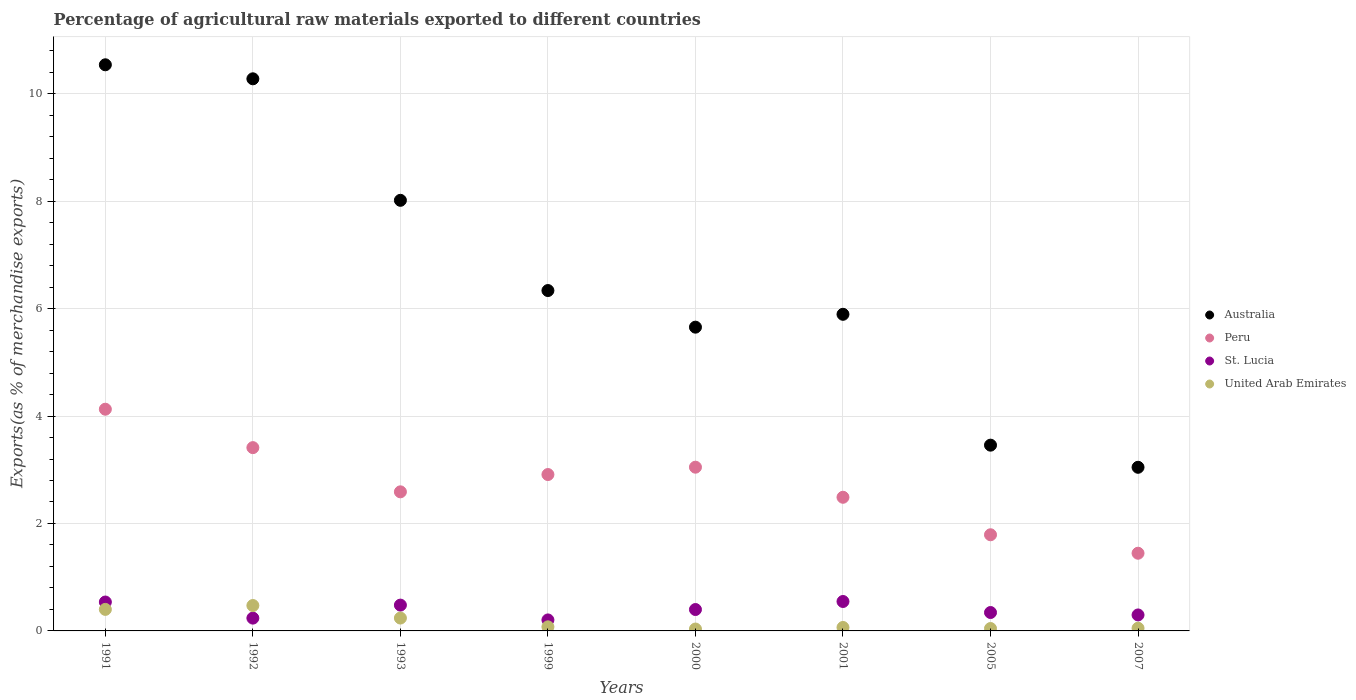What is the percentage of exports to different countries in Peru in 2001?
Your answer should be very brief. 2.49. Across all years, what is the maximum percentage of exports to different countries in Peru?
Provide a succinct answer. 4.13. Across all years, what is the minimum percentage of exports to different countries in St. Lucia?
Offer a terse response. 0.2. In which year was the percentage of exports to different countries in United Arab Emirates minimum?
Make the answer very short. 2000. What is the total percentage of exports to different countries in United Arab Emirates in the graph?
Your response must be concise. 1.38. What is the difference between the percentage of exports to different countries in United Arab Emirates in 2001 and that in 2005?
Offer a terse response. 0.02. What is the difference between the percentage of exports to different countries in United Arab Emirates in 1999 and the percentage of exports to different countries in Australia in 2001?
Provide a short and direct response. -5.82. What is the average percentage of exports to different countries in United Arab Emirates per year?
Make the answer very short. 0.17. In the year 2001, what is the difference between the percentage of exports to different countries in Australia and percentage of exports to different countries in United Arab Emirates?
Ensure brevity in your answer.  5.83. What is the ratio of the percentage of exports to different countries in Peru in 1993 to that in 2001?
Provide a succinct answer. 1.04. What is the difference between the highest and the second highest percentage of exports to different countries in Australia?
Your answer should be very brief. 0.26. What is the difference between the highest and the lowest percentage of exports to different countries in St. Lucia?
Provide a succinct answer. 0.34. Is the sum of the percentage of exports to different countries in St. Lucia in 1991 and 1993 greater than the maximum percentage of exports to different countries in Australia across all years?
Provide a succinct answer. No. Is it the case that in every year, the sum of the percentage of exports to different countries in United Arab Emirates and percentage of exports to different countries in Australia  is greater than the sum of percentage of exports to different countries in Peru and percentage of exports to different countries in St. Lucia?
Provide a succinct answer. Yes. Is the percentage of exports to different countries in United Arab Emirates strictly greater than the percentage of exports to different countries in St. Lucia over the years?
Keep it short and to the point. No. How many dotlines are there?
Your response must be concise. 4. Where does the legend appear in the graph?
Your answer should be very brief. Center right. How are the legend labels stacked?
Offer a very short reply. Vertical. What is the title of the graph?
Offer a terse response. Percentage of agricultural raw materials exported to different countries. What is the label or title of the X-axis?
Offer a terse response. Years. What is the label or title of the Y-axis?
Give a very brief answer. Exports(as % of merchandise exports). What is the Exports(as % of merchandise exports) in Australia in 1991?
Provide a succinct answer. 10.54. What is the Exports(as % of merchandise exports) in Peru in 1991?
Make the answer very short. 4.13. What is the Exports(as % of merchandise exports) in St. Lucia in 1991?
Offer a terse response. 0.54. What is the Exports(as % of merchandise exports) of United Arab Emirates in 1991?
Offer a very short reply. 0.4. What is the Exports(as % of merchandise exports) of Australia in 1992?
Offer a terse response. 10.28. What is the Exports(as % of merchandise exports) of Peru in 1992?
Offer a terse response. 3.41. What is the Exports(as % of merchandise exports) in St. Lucia in 1992?
Provide a short and direct response. 0.24. What is the Exports(as % of merchandise exports) in United Arab Emirates in 1992?
Your response must be concise. 0.47. What is the Exports(as % of merchandise exports) of Australia in 1993?
Your answer should be very brief. 8.02. What is the Exports(as % of merchandise exports) in Peru in 1993?
Make the answer very short. 2.59. What is the Exports(as % of merchandise exports) in St. Lucia in 1993?
Offer a very short reply. 0.48. What is the Exports(as % of merchandise exports) of United Arab Emirates in 1993?
Give a very brief answer. 0.24. What is the Exports(as % of merchandise exports) in Australia in 1999?
Provide a succinct answer. 6.34. What is the Exports(as % of merchandise exports) of Peru in 1999?
Offer a terse response. 2.91. What is the Exports(as % of merchandise exports) of St. Lucia in 1999?
Offer a very short reply. 0.2. What is the Exports(as % of merchandise exports) in United Arab Emirates in 1999?
Ensure brevity in your answer.  0.08. What is the Exports(as % of merchandise exports) of Australia in 2000?
Ensure brevity in your answer.  5.65. What is the Exports(as % of merchandise exports) in Peru in 2000?
Give a very brief answer. 3.05. What is the Exports(as % of merchandise exports) in St. Lucia in 2000?
Provide a succinct answer. 0.4. What is the Exports(as % of merchandise exports) of United Arab Emirates in 2000?
Provide a short and direct response. 0.04. What is the Exports(as % of merchandise exports) in Australia in 2001?
Give a very brief answer. 5.89. What is the Exports(as % of merchandise exports) of Peru in 2001?
Offer a terse response. 2.49. What is the Exports(as % of merchandise exports) in St. Lucia in 2001?
Ensure brevity in your answer.  0.55. What is the Exports(as % of merchandise exports) in United Arab Emirates in 2001?
Offer a very short reply. 0.06. What is the Exports(as % of merchandise exports) of Australia in 2005?
Offer a very short reply. 3.46. What is the Exports(as % of merchandise exports) of Peru in 2005?
Your response must be concise. 1.79. What is the Exports(as % of merchandise exports) of St. Lucia in 2005?
Your answer should be very brief. 0.34. What is the Exports(as % of merchandise exports) in United Arab Emirates in 2005?
Provide a succinct answer. 0.04. What is the Exports(as % of merchandise exports) of Australia in 2007?
Ensure brevity in your answer.  3.05. What is the Exports(as % of merchandise exports) of Peru in 2007?
Your answer should be very brief. 1.45. What is the Exports(as % of merchandise exports) of St. Lucia in 2007?
Make the answer very short. 0.3. What is the Exports(as % of merchandise exports) in United Arab Emirates in 2007?
Provide a short and direct response. 0.05. Across all years, what is the maximum Exports(as % of merchandise exports) in Australia?
Provide a succinct answer. 10.54. Across all years, what is the maximum Exports(as % of merchandise exports) of Peru?
Your answer should be very brief. 4.13. Across all years, what is the maximum Exports(as % of merchandise exports) in St. Lucia?
Keep it short and to the point. 0.55. Across all years, what is the maximum Exports(as % of merchandise exports) in United Arab Emirates?
Provide a short and direct response. 0.47. Across all years, what is the minimum Exports(as % of merchandise exports) of Australia?
Make the answer very short. 3.05. Across all years, what is the minimum Exports(as % of merchandise exports) of Peru?
Your answer should be compact. 1.45. Across all years, what is the minimum Exports(as % of merchandise exports) of St. Lucia?
Ensure brevity in your answer.  0.2. Across all years, what is the minimum Exports(as % of merchandise exports) of United Arab Emirates?
Provide a short and direct response. 0.04. What is the total Exports(as % of merchandise exports) in Australia in the graph?
Your answer should be very brief. 53.22. What is the total Exports(as % of merchandise exports) in Peru in the graph?
Your answer should be compact. 21.81. What is the total Exports(as % of merchandise exports) of St. Lucia in the graph?
Your answer should be very brief. 3.05. What is the total Exports(as % of merchandise exports) in United Arab Emirates in the graph?
Your response must be concise. 1.38. What is the difference between the Exports(as % of merchandise exports) of Australia in 1991 and that in 1992?
Ensure brevity in your answer.  0.26. What is the difference between the Exports(as % of merchandise exports) of Peru in 1991 and that in 1992?
Your answer should be very brief. 0.72. What is the difference between the Exports(as % of merchandise exports) in St. Lucia in 1991 and that in 1992?
Your answer should be very brief. 0.3. What is the difference between the Exports(as % of merchandise exports) in United Arab Emirates in 1991 and that in 1992?
Offer a very short reply. -0.07. What is the difference between the Exports(as % of merchandise exports) in Australia in 1991 and that in 1993?
Keep it short and to the point. 2.52. What is the difference between the Exports(as % of merchandise exports) in Peru in 1991 and that in 1993?
Provide a short and direct response. 1.54. What is the difference between the Exports(as % of merchandise exports) of St. Lucia in 1991 and that in 1993?
Your response must be concise. 0.06. What is the difference between the Exports(as % of merchandise exports) in United Arab Emirates in 1991 and that in 1993?
Provide a short and direct response. 0.16. What is the difference between the Exports(as % of merchandise exports) in Australia in 1991 and that in 1999?
Your response must be concise. 4.2. What is the difference between the Exports(as % of merchandise exports) in Peru in 1991 and that in 1999?
Your answer should be very brief. 1.22. What is the difference between the Exports(as % of merchandise exports) of St. Lucia in 1991 and that in 1999?
Provide a short and direct response. 0.33. What is the difference between the Exports(as % of merchandise exports) in United Arab Emirates in 1991 and that in 1999?
Provide a succinct answer. 0.32. What is the difference between the Exports(as % of merchandise exports) in Australia in 1991 and that in 2000?
Provide a short and direct response. 4.88. What is the difference between the Exports(as % of merchandise exports) of Peru in 1991 and that in 2000?
Make the answer very short. 1.08. What is the difference between the Exports(as % of merchandise exports) of St. Lucia in 1991 and that in 2000?
Your response must be concise. 0.14. What is the difference between the Exports(as % of merchandise exports) of United Arab Emirates in 1991 and that in 2000?
Ensure brevity in your answer.  0.37. What is the difference between the Exports(as % of merchandise exports) in Australia in 1991 and that in 2001?
Your answer should be very brief. 4.64. What is the difference between the Exports(as % of merchandise exports) of Peru in 1991 and that in 2001?
Provide a succinct answer. 1.64. What is the difference between the Exports(as % of merchandise exports) of St. Lucia in 1991 and that in 2001?
Keep it short and to the point. -0.01. What is the difference between the Exports(as % of merchandise exports) of United Arab Emirates in 1991 and that in 2001?
Keep it short and to the point. 0.34. What is the difference between the Exports(as % of merchandise exports) of Australia in 1991 and that in 2005?
Offer a terse response. 7.08. What is the difference between the Exports(as % of merchandise exports) in Peru in 1991 and that in 2005?
Offer a very short reply. 2.34. What is the difference between the Exports(as % of merchandise exports) of St. Lucia in 1991 and that in 2005?
Make the answer very short. 0.2. What is the difference between the Exports(as % of merchandise exports) in United Arab Emirates in 1991 and that in 2005?
Ensure brevity in your answer.  0.36. What is the difference between the Exports(as % of merchandise exports) in Australia in 1991 and that in 2007?
Ensure brevity in your answer.  7.49. What is the difference between the Exports(as % of merchandise exports) of Peru in 1991 and that in 2007?
Ensure brevity in your answer.  2.68. What is the difference between the Exports(as % of merchandise exports) of St. Lucia in 1991 and that in 2007?
Your response must be concise. 0.24. What is the difference between the Exports(as % of merchandise exports) in United Arab Emirates in 1991 and that in 2007?
Provide a succinct answer. 0.35. What is the difference between the Exports(as % of merchandise exports) in Australia in 1992 and that in 1993?
Ensure brevity in your answer.  2.26. What is the difference between the Exports(as % of merchandise exports) in Peru in 1992 and that in 1993?
Provide a short and direct response. 0.82. What is the difference between the Exports(as % of merchandise exports) in St. Lucia in 1992 and that in 1993?
Offer a terse response. -0.24. What is the difference between the Exports(as % of merchandise exports) in United Arab Emirates in 1992 and that in 1993?
Provide a short and direct response. 0.23. What is the difference between the Exports(as % of merchandise exports) in Australia in 1992 and that in 1999?
Your answer should be compact. 3.94. What is the difference between the Exports(as % of merchandise exports) in Peru in 1992 and that in 1999?
Make the answer very short. 0.5. What is the difference between the Exports(as % of merchandise exports) in St. Lucia in 1992 and that in 1999?
Offer a terse response. 0.03. What is the difference between the Exports(as % of merchandise exports) in United Arab Emirates in 1992 and that in 1999?
Offer a very short reply. 0.4. What is the difference between the Exports(as % of merchandise exports) in Australia in 1992 and that in 2000?
Keep it short and to the point. 4.62. What is the difference between the Exports(as % of merchandise exports) in Peru in 1992 and that in 2000?
Offer a terse response. 0.36. What is the difference between the Exports(as % of merchandise exports) of St. Lucia in 1992 and that in 2000?
Provide a short and direct response. -0.16. What is the difference between the Exports(as % of merchandise exports) in United Arab Emirates in 1992 and that in 2000?
Your response must be concise. 0.44. What is the difference between the Exports(as % of merchandise exports) of Australia in 1992 and that in 2001?
Provide a short and direct response. 4.38. What is the difference between the Exports(as % of merchandise exports) of Peru in 1992 and that in 2001?
Make the answer very short. 0.92. What is the difference between the Exports(as % of merchandise exports) in St. Lucia in 1992 and that in 2001?
Offer a terse response. -0.31. What is the difference between the Exports(as % of merchandise exports) in United Arab Emirates in 1992 and that in 2001?
Your answer should be compact. 0.41. What is the difference between the Exports(as % of merchandise exports) of Australia in 1992 and that in 2005?
Offer a terse response. 6.82. What is the difference between the Exports(as % of merchandise exports) of Peru in 1992 and that in 2005?
Provide a succinct answer. 1.62. What is the difference between the Exports(as % of merchandise exports) in St. Lucia in 1992 and that in 2005?
Ensure brevity in your answer.  -0.1. What is the difference between the Exports(as % of merchandise exports) in United Arab Emirates in 1992 and that in 2005?
Your response must be concise. 0.43. What is the difference between the Exports(as % of merchandise exports) of Australia in 1992 and that in 2007?
Give a very brief answer. 7.23. What is the difference between the Exports(as % of merchandise exports) in Peru in 1992 and that in 2007?
Your answer should be compact. 1.97. What is the difference between the Exports(as % of merchandise exports) of St. Lucia in 1992 and that in 2007?
Provide a short and direct response. -0.06. What is the difference between the Exports(as % of merchandise exports) in United Arab Emirates in 1992 and that in 2007?
Give a very brief answer. 0.42. What is the difference between the Exports(as % of merchandise exports) of Australia in 1993 and that in 1999?
Make the answer very short. 1.68. What is the difference between the Exports(as % of merchandise exports) in Peru in 1993 and that in 1999?
Offer a very short reply. -0.32. What is the difference between the Exports(as % of merchandise exports) in St. Lucia in 1993 and that in 1999?
Provide a short and direct response. 0.28. What is the difference between the Exports(as % of merchandise exports) of United Arab Emirates in 1993 and that in 1999?
Your answer should be compact. 0.16. What is the difference between the Exports(as % of merchandise exports) of Australia in 1993 and that in 2000?
Your answer should be compact. 2.36. What is the difference between the Exports(as % of merchandise exports) in Peru in 1993 and that in 2000?
Your answer should be very brief. -0.46. What is the difference between the Exports(as % of merchandise exports) of St. Lucia in 1993 and that in 2000?
Ensure brevity in your answer.  0.08. What is the difference between the Exports(as % of merchandise exports) of United Arab Emirates in 1993 and that in 2000?
Provide a succinct answer. 0.2. What is the difference between the Exports(as % of merchandise exports) of Australia in 1993 and that in 2001?
Give a very brief answer. 2.12. What is the difference between the Exports(as % of merchandise exports) in Peru in 1993 and that in 2001?
Make the answer very short. 0.1. What is the difference between the Exports(as % of merchandise exports) in St. Lucia in 1993 and that in 2001?
Keep it short and to the point. -0.07. What is the difference between the Exports(as % of merchandise exports) of United Arab Emirates in 1993 and that in 2001?
Provide a short and direct response. 0.17. What is the difference between the Exports(as % of merchandise exports) of Australia in 1993 and that in 2005?
Ensure brevity in your answer.  4.56. What is the difference between the Exports(as % of merchandise exports) in Peru in 1993 and that in 2005?
Keep it short and to the point. 0.8. What is the difference between the Exports(as % of merchandise exports) in St. Lucia in 1993 and that in 2005?
Ensure brevity in your answer.  0.14. What is the difference between the Exports(as % of merchandise exports) of United Arab Emirates in 1993 and that in 2005?
Give a very brief answer. 0.19. What is the difference between the Exports(as % of merchandise exports) of Australia in 1993 and that in 2007?
Offer a terse response. 4.97. What is the difference between the Exports(as % of merchandise exports) in Peru in 1993 and that in 2007?
Your response must be concise. 1.14. What is the difference between the Exports(as % of merchandise exports) in St. Lucia in 1993 and that in 2007?
Offer a terse response. 0.18. What is the difference between the Exports(as % of merchandise exports) in United Arab Emirates in 1993 and that in 2007?
Provide a short and direct response. 0.19. What is the difference between the Exports(as % of merchandise exports) in Australia in 1999 and that in 2000?
Offer a terse response. 0.68. What is the difference between the Exports(as % of merchandise exports) of Peru in 1999 and that in 2000?
Provide a succinct answer. -0.14. What is the difference between the Exports(as % of merchandise exports) in St. Lucia in 1999 and that in 2000?
Provide a succinct answer. -0.19. What is the difference between the Exports(as % of merchandise exports) of United Arab Emirates in 1999 and that in 2000?
Offer a terse response. 0.04. What is the difference between the Exports(as % of merchandise exports) in Australia in 1999 and that in 2001?
Your response must be concise. 0.44. What is the difference between the Exports(as % of merchandise exports) of Peru in 1999 and that in 2001?
Make the answer very short. 0.42. What is the difference between the Exports(as % of merchandise exports) of St. Lucia in 1999 and that in 2001?
Keep it short and to the point. -0.34. What is the difference between the Exports(as % of merchandise exports) in United Arab Emirates in 1999 and that in 2001?
Offer a very short reply. 0.01. What is the difference between the Exports(as % of merchandise exports) of Australia in 1999 and that in 2005?
Offer a very short reply. 2.88. What is the difference between the Exports(as % of merchandise exports) in Peru in 1999 and that in 2005?
Offer a terse response. 1.12. What is the difference between the Exports(as % of merchandise exports) in St. Lucia in 1999 and that in 2005?
Your answer should be compact. -0.14. What is the difference between the Exports(as % of merchandise exports) in United Arab Emirates in 1999 and that in 2005?
Provide a short and direct response. 0.03. What is the difference between the Exports(as % of merchandise exports) of Australia in 1999 and that in 2007?
Provide a short and direct response. 3.29. What is the difference between the Exports(as % of merchandise exports) in Peru in 1999 and that in 2007?
Make the answer very short. 1.47. What is the difference between the Exports(as % of merchandise exports) of St. Lucia in 1999 and that in 2007?
Make the answer very short. -0.09. What is the difference between the Exports(as % of merchandise exports) in United Arab Emirates in 1999 and that in 2007?
Give a very brief answer. 0.03. What is the difference between the Exports(as % of merchandise exports) of Australia in 2000 and that in 2001?
Offer a terse response. -0.24. What is the difference between the Exports(as % of merchandise exports) of Peru in 2000 and that in 2001?
Your answer should be very brief. 0.56. What is the difference between the Exports(as % of merchandise exports) of St. Lucia in 2000 and that in 2001?
Make the answer very short. -0.15. What is the difference between the Exports(as % of merchandise exports) in United Arab Emirates in 2000 and that in 2001?
Offer a terse response. -0.03. What is the difference between the Exports(as % of merchandise exports) of Australia in 2000 and that in 2005?
Your answer should be compact. 2.2. What is the difference between the Exports(as % of merchandise exports) of Peru in 2000 and that in 2005?
Provide a succinct answer. 1.26. What is the difference between the Exports(as % of merchandise exports) in St. Lucia in 2000 and that in 2005?
Keep it short and to the point. 0.06. What is the difference between the Exports(as % of merchandise exports) of United Arab Emirates in 2000 and that in 2005?
Offer a terse response. -0.01. What is the difference between the Exports(as % of merchandise exports) of Australia in 2000 and that in 2007?
Make the answer very short. 2.61. What is the difference between the Exports(as % of merchandise exports) of Peru in 2000 and that in 2007?
Make the answer very short. 1.6. What is the difference between the Exports(as % of merchandise exports) of St. Lucia in 2000 and that in 2007?
Your answer should be compact. 0.1. What is the difference between the Exports(as % of merchandise exports) in United Arab Emirates in 2000 and that in 2007?
Offer a terse response. -0.02. What is the difference between the Exports(as % of merchandise exports) in Australia in 2001 and that in 2005?
Offer a terse response. 2.44. What is the difference between the Exports(as % of merchandise exports) of Peru in 2001 and that in 2005?
Give a very brief answer. 0.7. What is the difference between the Exports(as % of merchandise exports) of St. Lucia in 2001 and that in 2005?
Provide a short and direct response. 0.21. What is the difference between the Exports(as % of merchandise exports) in United Arab Emirates in 2001 and that in 2005?
Your answer should be very brief. 0.02. What is the difference between the Exports(as % of merchandise exports) of Australia in 2001 and that in 2007?
Offer a terse response. 2.85. What is the difference between the Exports(as % of merchandise exports) of Peru in 2001 and that in 2007?
Your response must be concise. 1.04. What is the difference between the Exports(as % of merchandise exports) in St. Lucia in 2001 and that in 2007?
Ensure brevity in your answer.  0.25. What is the difference between the Exports(as % of merchandise exports) of United Arab Emirates in 2001 and that in 2007?
Give a very brief answer. 0.01. What is the difference between the Exports(as % of merchandise exports) in Australia in 2005 and that in 2007?
Make the answer very short. 0.41. What is the difference between the Exports(as % of merchandise exports) in Peru in 2005 and that in 2007?
Keep it short and to the point. 0.34. What is the difference between the Exports(as % of merchandise exports) of St. Lucia in 2005 and that in 2007?
Make the answer very short. 0.05. What is the difference between the Exports(as % of merchandise exports) in United Arab Emirates in 2005 and that in 2007?
Offer a very short reply. -0.01. What is the difference between the Exports(as % of merchandise exports) in Australia in 1991 and the Exports(as % of merchandise exports) in Peru in 1992?
Offer a terse response. 7.13. What is the difference between the Exports(as % of merchandise exports) of Australia in 1991 and the Exports(as % of merchandise exports) of St. Lucia in 1992?
Offer a very short reply. 10.3. What is the difference between the Exports(as % of merchandise exports) in Australia in 1991 and the Exports(as % of merchandise exports) in United Arab Emirates in 1992?
Provide a succinct answer. 10.07. What is the difference between the Exports(as % of merchandise exports) in Peru in 1991 and the Exports(as % of merchandise exports) in St. Lucia in 1992?
Your answer should be compact. 3.89. What is the difference between the Exports(as % of merchandise exports) of Peru in 1991 and the Exports(as % of merchandise exports) of United Arab Emirates in 1992?
Provide a short and direct response. 3.65. What is the difference between the Exports(as % of merchandise exports) of St. Lucia in 1991 and the Exports(as % of merchandise exports) of United Arab Emirates in 1992?
Keep it short and to the point. 0.07. What is the difference between the Exports(as % of merchandise exports) of Australia in 1991 and the Exports(as % of merchandise exports) of Peru in 1993?
Provide a short and direct response. 7.95. What is the difference between the Exports(as % of merchandise exports) in Australia in 1991 and the Exports(as % of merchandise exports) in St. Lucia in 1993?
Offer a very short reply. 10.06. What is the difference between the Exports(as % of merchandise exports) of Australia in 1991 and the Exports(as % of merchandise exports) of United Arab Emirates in 1993?
Your answer should be compact. 10.3. What is the difference between the Exports(as % of merchandise exports) in Peru in 1991 and the Exports(as % of merchandise exports) in St. Lucia in 1993?
Keep it short and to the point. 3.65. What is the difference between the Exports(as % of merchandise exports) in Peru in 1991 and the Exports(as % of merchandise exports) in United Arab Emirates in 1993?
Give a very brief answer. 3.89. What is the difference between the Exports(as % of merchandise exports) of St. Lucia in 1991 and the Exports(as % of merchandise exports) of United Arab Emirates in 1993?
Offer a terse response. 0.3. What is the difference between the Exports(as % of merchandise exports) of Australia in 1991 and the Exports(as % of merchandise exports) of Peru in 1999?
Your answer should be compact. 7.63. What is the difference between the Exports(as % of merchandise exports) in Australia in 1991 and the Exports(as % of merchandise exports) in St. Lucia in 1999?
Provide a short and direct response. 10.33. What is the difference between the Exports(as % of merchandise exports) in Australia in 1991 and the Exports(as % of merchandise exports) in United Arab Emirates in 1999?
Offer a very short reply. 10.46. What is the difference between the Exports(as % of merchandise exports) of Peru in 1991 and the Exports(as % of merchandise exports) of St. Lucia in 1999?
Your answer should be very brief. 3.92. What is the difference between the Exports(as % of merchandise exports) in Peru in 1991 and the Exports(as % of merchandise exports) in United Arab Emirates in 1999?
Offer a very short reply. 4.05. What is the difference between the Exports(as % of merchandise exports) of St. Lucia in 1991 and the Exports(as % of merchandise exports) of United Arab Emirates in 1999?
Ensure brevity in your answer.  0.46. What is the difference between the Exports(as % of merchandise exports) in Australia in 1991 and the Exports(as % of merchandise exports) in Peru in 2000?
Keep it short and to the point. 7.49. What is the difference between the Exports(as % of merchandise exports) in Australia in 1991 and the Exports(as % of merchandise exports) in St. Lucia in 2000?
Keep it short and to the point. 10.14. What is the difference between the Exports(as % of merchandise exports) of Australia in 1991 and the Exports(as % of merchandise exports) of United Arab Emirates in 2000?
Ensure brevity in your answer.  10.5. What is the difference between the Exports(as % of merchandise exports) of Peru in 1991 and the Exports(as % of merchandise exports) of St. Lucia in 2000?
Give a very brief answer. 3.73. What is the difference between the Exports(as % of merchandise exports) in Peru in 1991 and the Exports(as % of merchandise exports) in United Arab Emirates in 2000?
Your answer should be compact. 4.09. What is the difference between the Exports(as % of merchandise exports) in St. Lucia in 1991 and the Exports(as % of merchandise exports) in United Arab Emirates in 2000?
Your response must be concise. 0.5. What is the difference between the Exports(as % of merchandise exports) in Australia in 1991 and the Exports(as % of merchandise exports) in Peru in 2001?
Keep it short and to the point. 8.05. What is the difference between the Exports(as % of merchandise exports) of Australia in 1991 and the Exports(as % of merchandise exports) of St. Lucia in 2001?
Your answer should be compact. 9.99. What is the difference between the Exports(as % of merchandise exports) of Australia in 1991 and the Exports(as % of merchandise exports) of United Arab Emirates in 2001?
Give a very brief answer. 10.47. What is the difference between the Exports(as % of merchandise exports) of Peru in 1991 and the Exports(as % of merchandise exports) of St. Lucia in 2001?
Your answer should be very brief. 3.58. What is the difference between the Exports(as % of merchandise exports) in Peru in 1991 and the Exports(as % of merchandise exports) in United Arab Emirates in 2001?
Your response must be concise. 4.06. What is the difference between the Exports(as % of merchandise exports) in St. Lucia in 1991 and the Exports(as % of merchandise exports) in United Arab Emirates in 2001?
Make the answer very short. 0.47. What is the difference between the Exports(as % of merchandise exports) of Australia in 1991 and the Exports(as % of merchandise exports) of Peru in 2005?
Offer a very short reply. 8.75. What is the difference between the Exports(as % of merchandise exports) in Australia in 1991 and the Exports(as % of merchandise exports) in St. Lucia in 2005?
Keep it short and to the point. 10.2. What is the difference between the Exports(as % of merchandise exports) of Australia in 1991 and the Exports(as % of merchandise exports) of United Arab Emirates in 2005?
Ensure brevity in your answer.  10.49. What is the difference between the Exports(as % of merchandise exports) in Peru in 1991 and the Exports(as % of merchandise exports) in St. Lucia in 2005?
Offer a very short reply. 3.78. What is the difference between the Exports(as % of merchandise exports) of Peru in 1991 and the Exports(as % of merchandise exports) of United Arab Emirates in 2005?
Give a very brief answer. 4.08. What is the difference between the Exports(as % of merchandise exports) in St. Lucia in 1991 and the Exports(as % of merchandise exports) in United Arab Emirates in 2005?
Provide a short and direct response. 0.49. What is the difference between the Exports(as % of merchandise exports) in Australia in 1991 and the Exports(as % of merchandise exports) in Peru in 2007?
Your answer should be compact. 9.09. What is the difference between the Exports(as % of merchandise exports) of Australia in 1991 and the Exports(as % of merchandise exports) of St. Lucia in 2007?
Make the answer very short. 10.24. What is the difference between the Exports(as % of merchandise exports) in Australia in 1991 and the Exports(as % of merchandise exports) in United Arab Emirates in 2007?
Provide a short and direct response. 10.49. What is the difference between the Exports(as % of merchandise exports) in Peru in 1991 and the Exports(as % of merchandise exports) in St. Lucia in 2007?
Your answer should be very brief. 3.83. What is the difference between the Exports(as % of merchandise exports) of Peru in 1991 and the Exports(as % of merchandise exports) of United Arab Emirates in 2007?
Ensure brevity in your answer.  4.08. What is the difference between the Exports(as % of merchandise exports) in St. Lucia in 1991 and the Exports(as % of merchandise exports) in United Arab Emirates in 2007?
Offer a very short reply. 0.49. What is the difference between the Exports(as % of merchandise exports) of Australia in 1992 and the Exports(as % of merchandise exports) of Peru in 1993?
Provide a succinct answer. 7.69. What is the difference between the Exports(as % of merchandise exports) in Australia in 1992 and the Exports(as % of merchandise exports) in St. Lucia in 1993?
Keep it short and to the point. 9.8. What is the difference between the Exports(as % of merchandise exports) of Australia in 1992 and the Exports(as % of merchandise exports) of United Arab Emirates in 1993?
Provide a succinct answer. 10.04. What is the difference between the Exports(as % of merchandise exports) in Peru in 1992 and the Exports(as % of merchandise exports) in St. Lucia in 1993?
Your answer should be very brief. 2.93. What is the difference between the Exports(as % of merchandise exports) in Peru in 1992 and the Exports(as % of merchandise exports) in United Arab Emirates in 1993?
Your answer should be compact. 3.17. What is the difference between the Exports(as % of merchandise exports) in St. Lucia in 1992 and the Exports(as % of merchandise exports) in United Arab Emirates in 1993?
Provide a short and direct response. -0. What is the difference between the Exports(as % of merchandise exports) in Australia in 1992 and the Exports(as % of merchandise exports) in Peru in 1999?
Provide a succinct answer. 7.37. What is the difference between the Exports(as % of merchandise exports) in Australia in 1992 and the Exports(as % of merchandise exports) in St. Lucia in 1999?
Make the answer very short. 10.07. What is the difference between the Exports(as % of merchandise exports) in Australia in 1992 and the Exports(as % of merchandise exports) in United Arab Emirates in 1999?
Your answer should be very brief. 10.2. What is the difference between the Exports(as % of merchandise exports) of Peru in 1992 and the Exports(as % of merchandise exports) of St. Lucia in 1999?
Provide a short and direct response. 3.21. What is the difference between the Exports(as % of merchandise exports) in Peru in 1992 and the Exports(as % of merchandise exports) in United Arab Emirates in 1999?
Your response must be concise. 3.34. What is the difference between the Exports(as % of merchandise exports) of St. Lucia in 1992 and the Exports(as % of merchandise exports) of United Arab Emirates in 1999?
Keep it short and to the point. 0.16. What is the difference between the Exports(as % of merchandise exports) in Australia in 1992 and the Exports(as % of merchandise exports) in Peru in 2000?
Provide a short and direct response. 7.23. What is the difference between the Exports(as % of merchandise exports) of Australia in 1992 and the Exports(as % of merchandise exports) of St. Lucia in 2000?
Provide a succinct answer. 9.88. What is the difference between the Exports(as % of merchandise exports) of Australia in 1992 and the Exports(as % of merchandise exports) of United Arab Emirates in 2000?
Ensure brevity in your answer.  10.24. What is the difference between the Exports(as % of merchandise exports) of Peru in 1992 and the Exports(as % of merchandise exports) of St. Lucia in 2000?
Keep it short and to the point. 3.01. What is the difference between the Exports(as % of merchandise exports) of Peru in 1992 and the Exports(as % of merchandise exports) of United Arab Emirates in 2000?
Your response must be concise. 3.38. What is the difference between the Exports(as % of merchandise exports) of St. Lucia in 1992 and the Exports(as % of merchandise exports) of United Arab Emirates in 2000?
Make the answer very short. 0.2. What is the difference between the Exports(as % of merchandise exports) in Australia in 1992 and the Exports(as % of merchandise exports) in Peru in 2001?
Your answer should be very brief. 7.79. What is the difference between the Exports(as % of merchandise exports) in Australia in 1992 and the Exports(as % of merchandise exports) in St. Lucia in 2001?
Your answer should be compact. 9.73. What is the difference between the Exports(as % of merchandise exports) in Australia in 1992 and the Exports(as % of merchandise exports) in United Arab Emirates in 2001?
Keep it short and to the point. 10.21. What is the difference between the Exports(as % of merchandise exports) of Peru in 1992 and the Exports(as % of merchandise exports) of St. Lucia in 2001?
Ensure brevity in your answer.  2.86. What is the difference between the Exports(as % of merchandise exports) in Peru in 1992 and the Exports(as % of merchandise exports) in United Arab Emirates in 2001?
Your answer should be compact. 3.35. What is the difference between the Exports(as % of merchandise exports) in St. Lucia in 1992 and the Exports(as % of merchandise exports) in United Arab Emirates in 2001?
Make the answer very short. 0.17. What is the difference between the Exports(as % of merchandise exports) in Australia in 1992 and the Exports(as % of merchandise exports) in Peru in 2005?
Offer a terse response. 8.49. What is the difference between the Exports(as % of merchandise exports) of Australia in 1992 and the Exports(as % of merchandise exports) of St. Lucia in 2005?
Ensure brevity in your answer.  9.94. What is the difference between the Exports(as % of merchandise exports) of Australia in 1992 and the Exports(as % of merchandise exports) of United Arab Emirates in 2005?
Make the answer very short. 10.23. What is the difference between the Exports(as % of merchandise exports) of Peru in 1992 and the Exports(as % of merchandise exports) of St. Lucia in 2005?
Your answer should be compact. 3.07. What is the difference between the Exports(as % of merchandise exports) of Peru in 1992 and the Exports(as % of merchandise exports) of United Arab Emirates in 2005?
Keep it short and to the point. 3.37. What is the difference between the Exports(as % of merchandise exports) of St. Lucia in 1992 and the Exports(as % of merchandise exports) of United Arab Emirates in 2005?
Ensure brevity in your answer.  0.19. What is the difference between the Exports(as % of merchandise exports) of Australia in 1992 and the Exports(as % of merchandise exports) of Peru in 2007?
Provide a short and direct response. 8.83. What is the difference between the Exports(as % of merchandise exports) in Australia in 1992 and the Exports(as % of merchandise exports) in St. Lucia in 2007?
Give a very brief answer. 9.98. What is the difference between the Exports(as % of merchandise exports) of Australia in 1992 and the Exports(as % of merchandise exports) of United Arab Emirates in 2007?
Give a very brief answer. 10.23. What is the difference between the Exports(as % of merchandise exports) in Peru in 1992 and the Exports(as % of merchandise exports) in St. Lucia in 2007?
Provide a succinct answer. 3.11. What is the difference between the Exports(as % of merchandise exports) of Peru in 1992 and the Exports(as % of merchandise exports) of United Arab Emirates in 2007?
Offer a very short reply. 3.36. What is the difference between the Exports(as % of merchandise exports) in St. Lucia in 1992 and the Exports(as % of merchandise exports) in United Arab Emirates in 2007?
Give a very brief answer. 0.19. What is the difference between the Exports(as % of merchandise exports) of Australia in 1993 and the Exports(as % of merchandise exports) of Peru in 1999?
Your answer should be very brief. 5.1. What is the difference between the Exports(as % of merchandise exports) in Australia in 1993 and the Exports(as % of merchandise exports) in St. Lucia in 1999?
Your answer should be very brief. 7.81. What is the difference between the Exports(as % of merchandise exports) of Australia in 1993 and the Exports(as % of merchandise exports) of United Arab Emirates in 1999?
Make the answer very short. 7.94. What is the difference between the Exports(as % of merchandise exports) of Peru in 1993 and the Exports(as % of merchandise exports) of St. Lucia in 1999?
Offer a terse response. 2.38. What is the difference between the Exports(as % of merchandise exports) in Peru in 1993 and the Exports(as % of merchandise exports) in United Arab Emirates in 1999?
Keep it short and to the point. 2.51. What is the difference between the Exports(as % of merchandise exports) in St. Lucia in 1993 and the Exports(as % of merchandise exports) in United Arab Emirates in 1999?
Your answer should be compact. 0.4. What is the difference between the Exports(as % of merchandise exports) of Australia in 1993 and the Exports(as % of merchandise exports) of Peru in 2000?
Provide a succinct answer. 4.97. What is the difference between the Exports(as % of merchandise exports) of Australia in 1993 and the Exports(as % of merchandise exports) of St. Lucia in 2000?
Your answer should be compact. 7.62. What is the difference between the Exports(as % of merchandise exports) of Australia in 1993 and the Exports(as % of merchandise exports) of United Arab Emirates in 2000?
Provide a short and direct response. 7.98. What is the difference between the Exports(as % of merchandise exports) of Peru in 1993 and the Exports(as % of merchandise exports) of St. Lucia in 2000?
Keep it short and to the point. 2.19. What is the difference between the Exports(as % of merchandise exports) of Peru in 1993 and the Exports(as % of merchandise exports) of United Arab Emirates in 2000?
Provide a succinct answer. 2.55. What is the difference between the Exports(as % of merchandise exports) of St. Lucia in 1993 and the Exports(as % of merchandise exports) of United Arab Emirates in 2000?
Make the answer very short. 0.45. What is the difference between the Exports(as % of merchandise exports) of Australia in 1993 and the Exports(as % of merchandise exports) of Peru in 2001?
Offer a terse response. 5.53. What is the difference between the Exports(as % of merchandise exports) of Australia in 1993 and the Exports(as % of merchandise exports) of St. Lucia in 2001?
Your answer should be very brief. 7.47. What is the difference between the Exports(as % of merchandise exports) of Australia in 1993 and the Exports(as % of merchandise exports) of United Arab Emirates in 2001?
Ensure brevity in your answer.  7.95. What is the difference between the Exports(as % of merchandise exports) in Peru in 1993 and the Exports(as % of merchandise exports) in St. Lucia in 2001?
Provide a succinct answer. 2.04. What is the difference between the Exports(as % of merchandise exports) of Peru in 1993 and the Exports(as % of merchandise exports) of United Arab Emirates in 2001?
Ensure brevity in your answer.  2.52. What is the difference between the Exports(as % of merchandise exports) in St. Lucia in 1993 and the Exports(as % of merchandise exports) in United Arab Emirates in 2001?
Provide a succinct answer. 0.42. What is the difference between the Exports(as % of merchandise exports) in Australia in 1993 and the Exports(as % of merchandise exports) in Peru in 2005?
Give a very brief answer. 6.23. What is the difference between the Exports(as % of merchandise exports) of Australia in 1993 and the Exports(as % of merchandise exports) of St. Lucia in 2005?
Offer a very short reply. 7.67. What is the difference between the Exports(as % of merchandise exports) of Australia in 1993 and the Exports(as % of merchandise exports) of United Arab Emirates in 2005?
Offer a terse response. 7.97. What is the difference between the Exports(as % of merchandise exports) in Peru in 1993 and the Exports(as % of merchandise exports) in St. Lucia in 2005?
Provide a short and direct response. 2.25. What is the difference between the Exports(as % of merchandise exports) in Peru in 1993 and the Exports(as % of merchandise exports) in United Arab Emirates in 2005?
Make the answer very short. 2.54. What is the difference between the Exports(as % of merchandise exports) in St. Lucia in 1993 and the Exports(as % of merchandise exports) in United Arab Emirates in 2005?
Offer a terse response. 0.44. What is the difference between the Exports(as % of merchandise exports) of Australia in 1993 and the Exports(as % of merchandise exports) of Peru in 2007?
Make the answer very short. 6.57. What is the difference between the Exports(as % of merchandise exports) of Australia in 1993 and the Exports(as % of merchandise exports) of St. Lucia in 2007?
Give a very brief answer. 7.72. What is the difference between the Exports(as % of merchandise exports) of Australia in 1993 and the Exports(as % of merchandise exports) of United Arab Emirates in 2007?
Your answer should be very brief. 7.97. What is the difference between the Exports(as % of merchandise exports) of Peru in 1993 and the Exports(as % of merchandise exports) of St. Lucia in 2007?
Your answer should be compact. 2.29. What is the difference between the Exports(as % of merchandise exports) of Peru in 1993 and the Exports(as % of merchandise exports) of United Arab Emirates in 2007?
Your answer should be very brief. 2.54. What is the difference between the Exports(as % of merchandise exports) of St. Lucia in 1993 and the Exports(as % of merchandise exports) of United Arab Emirates in 2007?
Make the answer very short. 0.43. What is the difference between the Exports(as % of merchandise exports) in Australia in 1999 and the Exports(as % of merchandise exports) in Peru in 2000?
Make the answer very short. 3.29. What is the difference between the Exports(as % of merchandise exports) of Australia in 1999 and the Exports(as % of merchandise exports) of St. Lucia in 2000?
Your answer should be compact. 5.94. What is the difference between the Exports(as % of merchandise exports) in Australia in 1999 and the Exports(as % of merchandise exports) in United Arab Emirates in 2000?
Keep it short and to the point. 6.3. What is the difference between the Exports(as % of merchandise exports) in Peru in 1999 and the Exports(as % of merchandise exports) in St. Lucia in 2000?
Provide a succinct answer. 2.51. What is the difference between the Exports(as % of merchandise exports) of Peru in 1999 and the Exports(as % of merchandise exports) of United Arab Emirates in 2000?
Your answer should be very brief. 2.88. What is the difference between the Exports(as % of merchandise exports) of St. Lucia in 1999 and the Exports(as % of merchandise exports) of United Arab Emirates in 2000?
Offer a very short reply. 0.17. What is the difference between the Exports(as % of merchandise exports) in Australia in 1999 and the Exports(as % of merchandise exports) in Peru in 2001?
Your answer should be compact. 3.85. What is the difference between the Exports(as % of merchandise exports) in Australia in 1999 and the Exports(as % of merchandise exports) in St. Lucia in 2001?
Give a very brief answer. 5.79. What is the difference between the Exports(as % of merchandise exports) in Australia in 1999 and the Exports(as % of merchandise exports) in United Arab Emirates in 2001?
Give a very brief answer. 6.27. What is the difference between the Exports(as % of merchandise exports) in Peru in 1999 and the Exports(as % of merchandise exports) in St. Lucia in 2001?
Provide a succinct answer. 2.36. What is the difference between the Exports(as % of merchandise exports) in Peru in 1999 and the Exports(as % of merchandise exports) in United Arab Emirates in 2001?
Make the answer very short. 2.85. What is the difference between the Exports(as % of merchandise exports) in St. Lucia in 1999 and the Exports(as % of merchandise exports) in United Arab Emirates in 2001?
Make the answer very short. 0.14. What is the difference between the Exports(as % of merchandise exports) of Australia in 1999 and the Exports(as % of merchandise exports) of Peru in 2005?
Your answer should be compact. 4.55. What is the difference between the Exports(as % of merchandise exports) of Australia in 1999 and the Exports(as % of merchandise exports) of St. Lucia in 2005?
Give a very brief answer. 5.99. What is the difference between the Exports(as % of merchandise exports) in Australia in 1999 and the Exports(as % of merchandise exports) in United Arab Emirates in 2005?
Make the answer very short. 6.29. What is the difference between the Exports(as % of merchandise exports) of Peru in 1999 and the Exports(as % of merchandise exports) of St. Lucia in 2005?
Give a very brief answer. 2.57. What is the difference between the Exports(as % of merchandise exports) in Peru in 1999 and the Exports(as % of merchandise exports) in United Arab Emirates in 2005?
Your response must be concise. 2.87. What is the difference between the Exports(as % of merchandise exports) of St. Lucia in 1999 and the Exports(as % of merchandise exports) of United Arab Emirates in 2005?
Provide a short and direct response. 0.16. What is the difference between the Exports(as % of merchandise exports) in Australia in 1999 and the Exports(as % of merchandise exports) in Peru in 2007?
Provide a succinct answer. 4.89. What is the difference between the Exports(as % of merchandise exports) of Australia in 1999 and the Exports(as % of merchandise exports) of St. Lucia in 2007?
Keep it short and to the point. 6.04. What is the difference between the Exports(as % of merchandise exports) in Australia in 1999 and the Exports(as % of merchandise exports) in United Arab Emirates in 2007?
Provide a succinct answer. 6.29. What is the difference between the Exports(as % of merchandise exports) of Peru in 1999 and the Exports(as % of merchandise exports) of St. Lucia in 2007?
Your answer should be very brief. 2.61. What is the difference between the Exports(as % of merchandise exports) of Peru in 1999 and the Exports(as % of merchandise exports) of United Arab Emirates in 2007?
Your response must be concise. 2.86. What is the difference between the Exports(as % of merchandise exports) of St. Lucia in 1999 and the Exports(as % of merchandise exports) of United Arab Emirates in 2007?
Ensure brevity in your answer.  0.15. What is the difference between the Exports(as % of merchandise exports) in Australia in 2000 and the Exports(as % of merchandise exports) in Peru in 2001?
Make the answer very short. 3.17. What is the difference between the Exports(as % of merchandise exports) in Australia in 2000 and the Exports(as % of merchandise exports) in St. Lucia in 2001?
Provide a short and direct response. 5.11. What is the difference between the Exports(as % of merchandise exports) of Australia in 2000 and the Exports(as % of merchandise exports) of United Arab Emirates in 2001?
Provide a succinct answer. 5.59. What is the difference between the Exports(as % of merchandise exports) of Peru in 2000 and the Exports(as % of merchandise exports) of St. Lucia in 2001?
Provide a short and direct response. 2.5. What is the difference between the Exports(as % of merchandise exports) in Peru in 2000 and the Exports(as % of merchandise exports) in United Arab Emirates in 2001?
Offer a very short reply. 2.98. What is the difference between the Exports(as % of merchandise exports) of St. Lucia in 2000 and the Exports(as % of merchandise exports) of United Arab Emirates in 2001?
Make the answer very short. 0.33. What is the difference between the Exports(as % of merchandise exports) in Australia in 2000 and the Exports(as % of merchandise exports) in Peru in 2005?
Offer a terse response. 3.86. What is the difference between the Exports(as % of merchandise exports) in Australia in 2000 and the Exports(as % of merchandise exports) in St. Lucia in 2005?
Provide a succinct answer. 5.31. What is the difference between the Exports(as % of merchandise exports) of Australia in 2000 and the Exports(as % of merchandise exports) of United Arab Emirates in 2005?
Your answer should be very brief. 5.61. What is the difference between the Exports(as % of merchandise exports) in Peru in 2000 and the Exports(as % of merchandise exports) in St. Lucia in 2005?
Your answer should be very brief. 2.71. What is the difference between the Exports(as % of merchandise exports) in Peru in 2000 and the Exports(as % of merchandise exports) in United Arab Emirates in 2005?
Offer a terse response. 3. What is the difference between the Exports(as % of merchandise exports) in St. Lucia in 2000 and the Exports(as % of merchandise exports) in United Arab Emirates in 2005?
Your response must be concise. 0.35. What is the difference between the Exports(as % of merchandise exports) in Australia in 2000 and the Exports(as % of merchandise exports) in Peru in 2007?
Offer a very short reply. 4.21. What is the difference between the Exports(as % of merchandise exports) of Australia in 2000 and the Exports(as % of merchandise exports) of St. Lucia in 2007?
Offer a very short reply. 5.36. What is the difference between the Exports(as % of merchandise exports) of Australia in 2000 and the Exports(as % of merchandise exports) of United Arab Emirates in 2007?
Offer a terse response. 5.6. What is the difference between the Exports(as % of merchandise exports) in Peru in 2000 and the Exports(as % of merchandise exports) in St. Lucia in 2007?
Your response must be concise. 2.75. What is the difference between the Exports(as % of merchandise exports) in Peru in 2000 and the Exports(as % of merchandise exports) in United Arab Emirates in 2007?
Give a very brief answer. 3. What is the difference between the Exports(as % of merchandise exports) of St. Lucia in 2000 and the Exports(as % of merchandise exports) of United Arab Emirates in 2007?
Offer a very short reply. 0.35. What is the difference between the Exports(as % of merchandise exports) in Australia in 2001 and the Exports(as % of merchandise exports) in Peru in 2005?
Provide a succinct answer. 4.1. What is the difference between the Exports(as % of merchandise exports) of Australia in 2001 and the Exports(as % of merchandise exports) of St. Lucia in 2005?
Your answer should be very brief. 5.55. What is the difference between the Exports(as % of merchandise exports) in Australia in 2001 and the Exports(as % of merchandise exports) in United Arab Emirates in 2005?
Your response must be concise. 5.85. What is the difference between the Exports(as % of merchandise exports) in Peru in 2001 and the Exports(as % of merchandise exports) in St. Lucia in 2005?
Offer a terse response. 2.15. What is the difference between the Exports(as % of merchandise exports) of Peru in 2001 and the Exports(as % of merchandise exports) of United Arab Emirates in 2005?
Provide a short and direct response. 2.44. What is the difference between the Exports(as % of merchandise exports) in St. Lucia in 2001 and the Exports(as % of merchandise exports) in United Arab Emirates in 2005?
Ensure brevity in your answer.  0.5. What is the difference between the Exports(as % of merchandise exports) in Australia in 2001 and the Exports(as % of merchandise exports) in Peru in 2007?
Keep it short and to the point. 4.45. What is the difference between the Exports(as % of merchandise exports) in Australia in 2001 and the Exports(as % of merchandise exports) in St. Lucia in 2007?
Your answer should be compact. 5.6. What is the difference between the Exports(as % of merchandise exports) in Australia in 2001 and the Exports(as % of merchandise exports) in United Arab Emirates in 2007?
Provide a short and direct response. 5.84. What is the difference between the Exports(as % of merchandise exports) of Peru in 2001 and the Exports(as % of merchandise exports) of St. Lucia in 2007?
Offer a very short reply. 2.19. What is the difference between the Exports(as % of merchandise exports) of Peru in 2001 and the Exports(as % of merchandise exports) of United Arab Emirates in 2007?
Make the answer very short. 2.44. What is the difference between the Exports(as % of merchandise exports) in St. Lucia in 2001 and the Exports(as % of merchandise exports) in United Arab Emirates in 2007?
Provide a short and direct response. 0.5. What is the difference between the Exports(as % of merchandise exports) of Australia in 2005 and the Exports(as % of merchandise exports) of Peru in 2007?
Make the answer very short. 2.01. What is the difference between the Exports(as % of merchandise exports) of Australia in 2005 and the Exports(as % of merchandise exports) of St. Lucia in 2007?
Provide a short and direct response. 3.16. What is the difference between the Exports(as % of merchandise exports) in Australia in 2005 and the Exports(as % of merchandise exports) in United Arab Emirates in 2007?
Keep it short and to the point. 3.41. What is the difference between the Exports(as % of merchandise exports) in Peru in 2005 and the Exports(as % of merchandise exports) in St. Lucia in 2007?
Your answer should be compact. 1.49. What is the difference between the Exports(as % of merchandise exports) in Peru in 2005 and the Exports(as % of merchandise exports) in United Arab Emirates in 2007?
Offer a terse response. 1.74. What is the difference between the Exports(as % of merchandise exports) of St. Lucia in 2005 and the Exports(as % of merchandise exports) of United Arab Emirates in 2007?
Provide a succinct answer. 0.29. What is the average Exports(as % of merchandise exports) of Australia per year?
Your answer should be compact. 6.65. What is the average Exports(as % of merchandise exports) in Peru per year?
Give a very brief answer. 2.73. What is the average Exports(as % of merchandise exports) of St. Lucia per year?
Your answer should be very brief. 0.38. What is the average Exports(as % of merchandise exports) of United Arab Emirates per year?
Give a very brief answer. 0.17. In the year 1991, what is the difference between the Exports(as % of merchandise exports) of Australia and Exports(as % of merchandise exports) of Peru?
Offer a terse response. 6.41. In the year 1991, what is the difference between the Exports(as % of merchandise exports) in Australia and Exports(as % of merchandise exports) in St. Lucia?
Make the answer very short. 10. In the year 1991, what is the difference between the Exports(as % of merchandise exports) of Australia and Exports(as % of merchandise exports) of United Arab Emirates?
Your answer should be compact. 10.14. In the year 1991, what is the difference between the Exports(as % of merchandise exports) in Peru and Exports(as % of merchandise exports) in St. Lucia?
Keep it short and to the point. 3.59. In the year 1991, what is the difference between the Exports(as % of merchandise exports) of Peru and Exports(as % of merchandise exports) of United Arab Emirates?
Your answer should be compact. 3.73. In the year 1991, what is the difference between the Exports(as % of merchandise exports) of St. Lucia and Exports(as % of merchandise exports) of United Arab Emirates?
Make the answer very short. 0.14. In the year 1992, what is the difference between the Exports(as % of merchandise exports) in Australia and Exports(as % of merchandise exports) in Peru?
Make the answer very short. 6.87. In the year 1992, what is the difference between the Exports(as % of merchandise exports) in Australia and Exports(as % of merchandise exports) in St. Lucia?
Offer a very short reply. 10.04. In the year 1992, what is the difference between the Exports(as % of merchandise exports) of Australia and Exports(as % of merchandise exports) of United Arab Emirates?
Offer a terse response. 9.81. In the year 1992, what is the difference between the Exports(as % of merchandise exports) in Peru and Exports(as % of merchandise exports) in St. Lucia?
Give a very brief answer. 3.17. In the year 1992, what is the difference between the Exports(as % of merchandise exports) of Peru and Exports(as % of merchandise exports) of United Arab Emirates?
Keep it short and to the point. 2.94. In the year 1992, what is the difference between the Exports(as % of merchandise exports) in St. Lucia and Exports(as % of merchandise exports) in United Arab Emirates?
Keep it short and to the point. -0.23. In the year 1993, what is the difference between the Exports(as % of merchandise exports) in Australia and Exports(as % of merchandise exports) in Peru?
Your answer should be very brief. 5.43. In the year 1993, what is the difference between the Exports(as % of merchandise exports) in Australia and Exports(as % of merchandise exports) in St. Lucia?
Ensure brevity in your answer.  7.54. In the year 1993, what is the difference between the Exports(as % of merchandise exports) of Australia and Exports(as % of merchandise exports) of United Arab Emirates?
Provide a short and direct response. 7.78. In the year 1993, what is the difference between the Exports(as % of merchandise exports) of Peru and Exports(as % of merchandise exports) of St. Lucia?
Provide a succinct answer. 2.11. In the year 1993, what is the difference between the Exports(as % of merchandise exports) of Peru and Exports(as % of merchandise exports) of United Arab Emirates?
Provide a succinct answer. 2.35. In the year 1993, what is the difference between the Exports(as % of merchandise exports) of St. Lucia and Exports(as % of merchandise exports) of United Arab Emirates?
Your answer should be very brief. 0.24. In the year 1999, what is the difference between the Exports(as % of merchandise exports) of Australia and Exports(as % of merchandise exports) of Peru?
Give a very brief answer. 3.43. In the year 1999, what is the difference between the Exports(as % of merchandise exports) of Australia and Exports(as % of merchandise exports) of St. Lucia?
Provide a succinct answer. 6.13. In the year 1999, what is the difference between the Exports(as % of merchandise exports) of Australia and Exports(as % of merchandise exports) of United Arab Emirates?
Keep it short and to the point. 6.26. In the year 1999, what is the difference between the Exports(as % of merchandise exports) of Peru and Exports(as % of merchandise exports) of St. Lucia?
Offer a very short reply. 2.71. In the year 1999, what is the difference between the Exports(as % of merchandise exports) in Peru and Exports(as % of merchandise exports) in United Arab Emirates?
Your answer should be compact. 2.84. In the year 1999, what is the difference between the Exports(as % of merchandise exports) of St. Lucia and Exports(as % of merchandise exports) of United Arab Emirates?
Offer a terse response. 0.13. In the year 2000, what is the difference between the Exports(as % of merchandise exports) in Australia and Exports(as % of merchandise exports) in Peru?
Offer a very short reply. 2.61. In the year 2000, what is the difference between the Exports(as % of merchandise exports) of Australia and Exports(as % of merchandise exports) of St. Lucia?
Make the answer very short. 5.26. In the year 2000, what is the difference between the Exports(as % of merchandise exports) of Australia and Exports(as % of merchandise exports) of United Arab Emirates?
Ensure brevity in your answer.  5.62. In the year 2000, what is the difference between the Exports(as % of merchandise exports) of Peru and Exports(as % of merchandise exports) of St. Lucia?
Make the answer very short. 2.65. In the year 2000, what is the difference between the Exports(as % of merchandise exports) in Peru and Exports(as % of merchandise exports) in United Arab Emirates?
Your answer should be compact. 3.01. In the year 2000, what is the difference between the Exports(as % of merchandise exports) of St. Lucia and Exports(as % of merchandise exports) of United Arab Emirates?
Your answer should be very brief. 0.36. In the year 2001, what is the difference between the Exports(as % of merchandise exports) of Australia and Exports(as % of merchandise exports) of Peru?
Make the answer very short. 3.41. In the year 2001, what is the difference between the Exports(as % of merchandise exports) in Australia and Exports(as % of merchandise exports) in St. Lucia?
Give a very brief answer. 5.35. In the year 2001, what is the difference between the Exports(as % of merchandise exports) of Australia and Exports(as % of merchandise exports) of United Arab Emirates?
Provide a succinct answer. 5.83. In the year 2001, what is the difference between the Exports(as % of merchandise exports) in Peru and Exports(as % of merchandise exports) in St. Lucia?
Ensure brevity in your answer.  1.94. In the year 2001, what is the difference between the Exports(as % of merchandise exports) of Peru and Exports(as % of merchandise exports) of United Arab Emirates?
Ensure brevity in your answer.  2.42. In the year 2001, what is the difference between the Exports(as % of merchandise exports) in St. Lucia and Exports(as % of merchandise exports) in United Arab Emirates?
Your answer should be compact. 0.48. In the year 2005, what is the difference between the Exports(as % of merchandise exports) in Australia and Exports(as % of merchandise exports) in Peru?
Keep it short and to the point. 1.67. In the year 2005, what is the difference between the Exports(as % of merchandise exports) in Australia and Exports(as % of merchandise exports) in St. Lucia?
Give a very brief answer. 3.12. In the year 2005, what is the difference between the Exports(as % of merchandise exports) of Australia and Exports(as % of merchandise exports) of United Arab Emirates?
Give a very brief answer. 3.41. In the year 2005, what is the difference between the Exports(as % of merchandise exports) of Peru and Exports(as % of merchandise exports) of St. Lucia?
Keep it short and to the point. 1.45. In the year 2005, what is the difference between the Exports(as % of merchandise exports) of Peru and Exports(as % of merchandise exports) of United Arab Emirates?
Your answer should be compact. 1.75. In the year 2005, what is the difference between the Exports(as % of merchandise exports) in St. Lucia and Exports(as % of merchandise exports) in United Arab Emirates?
Offer a very short reply. 0.3. In the year 2007, what is the difference between the Exports(as % of merchandise exports) of Australia and Exports(as % of merchandise exports) of Peru?
Your answer should be compact. 1.6. In the year 2007, what is the difference between the Exports(as % of merchandise exports) of Australia and Exports(as % of merchandise exports) of St. Lucia?
Make the answer very short. 2.75. In the year 2007, what is the difference between the Exports(as % of merchandise exports) of Australia and Exports(as % of merchandise exports) of United Arab Emirates?
Your response must be concise. 3. In the year 2007, what is the difference between the Exports(as % of merchandise exports) in Peru and Exports(as % of merchandise exports) in St. Lucia?
Ensure brevity in your answer.  1.15. In the year 2007, what is the difference between the Exports(as % of merchandise exports) in Peru and Exports(as % of merchandise exports) in United Arab Emirates?
Your response must be concise. 1.4. In the year 2007, what is the difference between the Exports(as % of merchandise exports) in St. Lucia and Exports(as % of merchandise exports) in United Arab Emirates?
Give a very brief answer. 0.25. What is the ratio of the Exports(as % of merchandise exports) in Australia in 1991 to that in 1992?
Offer a terse response. 1.03. What is the ratio of the Exports(as % of merchandise exports) in Peru in 1991 to that in 1992?
Provide a short and direct response. 1.21. What is the ratio of the Exports(as % of merchandise exports) of St. Lucia in 1991 to that in 1992?
Ensure brevity in your answer.  2.26. What is the ratio of the Exports(as % of merchandise exports) in United Arab Emirates in 1991 to that in 1992?
Offer a very short reply. 0.85. What is the ratio of the Exports(as % of merchandise exports) of Australia in 1991 to that in 1993?
Ensure brevity in your answer.  1.31. What is the ratio of the Exports(as % of merchandise exports) in Peru in 1991 to that in 1993?
Ensure brevity in your answer.  1.59. What is the ratio of the Exports(as % of merchandise exports) in St. Lucia in 1991 to that in 1993?
Your answer should be very brief. 1.12. What is the ratio of the Exports(as % of merchandise exports) of United Arab Emirates in 1991 to that in 1993?
Ensure brevity in your answer.  1.67. What is the ratio of the Exports(as % of merchandise exports) of Australia in 1991 to that in 1999?
Offer a terse response. 1.66. What is the ratio of the Exports(as % of merchandise exports) of Peru in 1991 to that in 1999?
Provide a succinct answer. 1.42. What is the ratio of the Exports(as % of merchandise exports) in St. Lucia in 1991 to that in 1999?
Provide a succinct answer. 2.63. What is the ratio of the Exports(as % of merchandise exports) of United Arab Emirates in 1991 to that in 1999?
Offer a very short reply. 5.28. What is the ratio of the Exports(as % of merchandise exports) of Australia in 1991 to that in 2000?
Your answer should be very brief. 1.86. What is the ratio of the Exports(as % of merchandise exports) of Peru in 1991 to that in 2000?
Your answer should be very brief. 1.35. What is the ratio of the Exports(as % of merchandise exports) in St. Lucia in 1991 to that in 2000?
Your answer should be compact. 1.35. What is the ratio of the Exports(as % of merchandise exports) of United Arab Emirates in 1991 to that in 2000?
Ensure brevity in your answer.  11.43. What is the ratio of the Exports(as % of merchandise exports) of Australia in 1991 to that in 2001?
Your answer should be compact. 1.79. What is the ratio of the Exports(as % of merchandise exports) in Peru in 1991 to that in 2001?
Offer a terse response. 1.66. What is the ratio of the Exports(as % of merchandise exports) of St. Lucia in 1991 to that in 2001?
Offer a terse response. 0.98. What is the ratio of the Exports(as % of merchandise exports) in United Arab Emirates in 1991 to that in 2001?
Provide a succinct answer. 6.23. What is the ratio of the Exports(as % of merchandise exports) of Australia in 1991 to that in 2005?
Offer a very short reply. 3.05. What is the ratio of the Exports(as % of merchandise exports) of Peru in 1991 to that in 2005?
Ensure brevity in your answer.  2.31. What is the ratio of the Exports(as % of merchandise exports) of St. Lucia in 1991 to that in 2005?
Your answer should be very brief. 1.57. What is the ratio of the Exports(as % of merchandise exports) in United Arab Emirates in 1991 to that in 2005?
Your answer should be compact. 8.97. What is the ratio of the Exports(as % of merchandise exports) in Australia in 1991 to that in 2007?
Provide a succinct answer. 3.46. What is the ratio of the Exports(as % of merchandise exports) in Peru in 1991 to that in 2007?
Keep it short and to the point. 2.85. What is the ratio of the Exports(as % of merchandise exports) of St. Lucia in 1991 to that in 2007?
Keep it short and to the point. 1.81. What is the ratio of the Exports(as % of merchandise exports) in United Arab Emirates in 1991 to that in 2007?
Make the answer very short. 7.93. What is the ratio of the Exports(as % of merchandise exports) in Australia in 1992 to that in 1993?
Provide a succinct answer. 1.28. What is the ratio of the Exports(as % of merchandise exports) in Peru in 1992 to that in 1993?
Offer a terse response. 1.32. What is the ratio of the Exports(as % of merchandise exports) in St. Lucia in 1992 to that in 1993?
Ensure brevity in your answer.  0.5. What is the ratio of the Exports(as % of merchandise exports) of United Arab Emirates in 1992 to that in 1993?
Offer a very short reply. 1.98. What is the ratio of the Exports(as % of merchandise exports) in Australia in 1992 to that in 1999?
Your answer should be compact. 1.62. What is the ratio of the Exports(as % of merchandise exports) in Peru in 1992 to that in 1999?
Offer a very short reply. 1.17. What is the ratio of the Exports(as % of merchandise exports) in St. Lucia in 1992 to that in 1999?
Ensure brevity in your answer.  1.16. What is the ratio of the Exports(as % of merchandise exports) in United Arab Emirates in 1992 to that in 1999?
Offer a terse response. 6.23. What is the ratio of the Exports(as % of merchandise exports) of Australia in 1992 to that in 2000?
Offer a terse response. 1.82. What is the ratio of the Exports(as % of merchandise exports) of Peru in 1992 to that in 2000?
Offer a terse response. 1.12. What is the ratio of the Exports(as % of merchandise exports) in St. Lucia in 1992 to that in 2000?
Your answer should be compact. 0.6. What is the ratio of the Exports(as % of merchandise exports) of United Arab Emirates in 1992 to that in 2000?
Offer a terse response. 13.48. What is the ratio of the Exports(as % of merchandise exports) in Australia in 1992 to that in 2001?
Offer a very short reply. 1.74. What is the ratio of the Exports(as % of merchandise exports) of Peru in 1992 to that in 2001?
Your answer should be very brief. 1.37. What is the ratio of the Exports(as % of merchandise exports) in St. Lucia in 1992 to that in 2001?
Provide a short and direct response. 0.43. What is the ratio of the Exports(as % of merchandise exports) in United Arab Emirates in 1992 to that in 2001?
Give a very brief answer. 7.35. What is the ratio of the Exports(as % of merchandise exports) of Australia in 1992 to that in 2005?
Your response must be concise. 2.97. What is the ratio of the Exports(as % of merchandise exports) of Peru in 1992 to that in 2005?
Your answer should be very brief. 1.91. What is the ratio of the Exports(as % of merchandise exports) in St. Lucia in 1992 to that in 2005?
Your response must be concise. 0.7. What is the ratio of the Exports(as % of merchandise exports) of United Arab Emirates in 1992 to that in 2005?
Your answer should be very brief. 10.58. What is the ratio of the Exports(as % of merchandise exports) of Australia in 1992 to that in 2007?
Your answer should be compact. 3.37. What is the ratio of the Exports(as % of merchandise exports) in Peru in 1992 to that in 2007?
Provide a short and direct response. 2.36. What is the ratio of the Exports(as % of merchandise exports) in St. Lucia in 1992 to that in 2007?
Your answer should be very brief. 0.8. What is the ratio of the Exports(as % of merchandise exports) of United Arab Emirates in 1992 to that in 2007?
Your answer should be very brief. 9.36. What is the ratio of the Exports(as % of merchandise exports) of Australia in 1993 to that in 1999?
Offer a terse response. 1.27. What is the ratio of the Exports(as % of merchandise exports) of Peru in 1993 to that in 1999?
Ensure brevity in your answer.  0.89. What is the ratio of the Exports(as % of merchandise exports) in St. Lucia in 1993 to that in 1999?
Make the answer very short. 2.35. What is the ratio of the Exports(as % of merchandise exports) of United Arab Emirates in 1993 to that in 1999?
Keep it short and to the point. 3.15. What is the ratio of the Exports(as % of merchandise exports) of Australia in 1993 to that in 2000?
Offer a terse response. 1.42. What is the ratio of the Exports(as % of merchandise exports) of Peru in 1993 to that in 2000?
Ensure brevity in your answer.  0.85. What is the ratio of the Exports(as % of merchandise exports) in St. Lucia in 1993 to that in 2000?
Give a very brief answer. 1.21. What is the ratio of the Exports(as % of merchandise exports) of United Arab Emirates in 1993 to that in 2000?
Give a very brief answer. 6.83. What is the ratio of the Exports(as % of merchandise exports) of Australia in 1993 to that in 2001?
Your answer should be very brief. 1.36. What is the ratio of the Exports(as % of merchandise exports) in Peru in 1993 to that in 2001?
Make the answer very short. 1.04. What is the ratio of the Exports(as % of merchandise exports) in St. Lucia in 1993 to that in 2001?
Provide a succinct answer. 0.88. What is the ratio of the Exports(as % of merchandise exports) in United Arab Emirates in 1993 to that in 2001?
Offer a very short reply. 3.72. What is the ratio of the Exports(as % of merchandise exports) of Australia in 1993 to that in 2005?
Keep it short and to the point. 2.32. What is the ratio of the Exports(as % of merchandise exports) in Peru in 1993 to that in 2005?
Make the answer very short. 1.45. What is the ratio of the Exports(as % of merchandise exports) of St. Lucia in 1993 to that in 2005?
Provide a short and direct response. 1.4. What is the ratio of the Exports(as % of merchandise exports) in United Arab Emirates in 1993 to that in 2005?
Offer a very short reply. 5.36. What is the ratio of the Exports(as % of merchandise exports) of Australia in 1993 to that in 2007?
Your answer should be compact. 2.63. What is the ratio of the Exports(as % of merchandise exports) of Peru in 1993 to that in 2007?
Your answer should be compact. 1.79. What is the ratio of the Exports(as % of merchandise exports) of St. Lucia in 1993 to that in 2007?
Ensure brevity in your answer.  1.62. What is the ratio of the Exports(as % of merchandise exports) in United Arab Emirates in 1993 to that in 2007?
Give a very brief answer. 4.74. What is the ratio of the Exports(as % of merchandise exports) in Australia in 1999 to that in 2000?
Provide a succinct answer. 1.12. What is the ratio of the Exports(as % of merchandise exports) in Peru in 1999 to that in 2000?
Give a very brief answer. 0.96. What is the ratio of the Exports(as % of merchandise exports) of St. Lucia in 1999 to that in 2000?
Ensure brevity in your answer.  0.51. What is the ratio of the Exports(as % of merchandise exports) of United Arab Emirates in 1999 to that in 2000?
Provide a short and direct response. 2.17. What is the ratio of the Exports(as % of merchandise exports) in Australia in 1999 to that in 2001?
Make the answer very short. 1.07. What is the ratio of the Exports(as % of merchandise exports) in Peru in 1999 to that in 2001?
Provide a succinct answer. 1.17. What is the ratio of the Exports(as % of merchandise exports) in St. Lucia in 1999 to that in 2001?
Provide a short and direct response. 0.37. What is the ratio of the Exports(as % of merchandise exports) in United Arab Emirates in 1999 to that in 2001?
Your answer should be very brief. 1.18. What is the ratio of the Exports(as % of merchandise exports) of Australia in 1999 to that in 2005?
Your answer should be compact. 1.83. What is the ratio of the Exports(as % of merchandise exports) of Peru in 1999 to that in 2005?
Provide a succinct answer. 1.63. What is the ratio of the Exports(as % of merchandise exports) of St. Lucia in 1999 to that in 2005?
Ensure brevity in your answer.  0.6. What is the ratio of the Exports(as % of merchandise exports) of United Arab Emirates in 1999 to that in 2005?
Ensure brevity in your answer.  1.7. What is the ratio of the Exports(as % of merchandise exports) of Australia in 1999 to that in 2007?
Keep it short and to the point. 2.08. What is the ratio of the Exports(as % of merchandise exports) of Peru in 1999 to that in 2007?
Provide a short and direct response. 2.01. What is the ratio of the Exports(as % of merchandise exports) of St. Lucia in 1999 to that in 2007?
Your answer should be very brief. 0.69. What is the ratio of the Exports(as % of merchandise exports) of United Arab Emirates in 1999 to that in 2007?
Give a very brief answer. 1.5. What is the ratio of the Exports(as % of merchandise exports) of Australia in 2000 to that in 2001?
Provide a succinct answer. 0.96. What is the ratio of the Exports(as % of merchandise exports) in Peru in 2000 to that in 2001?
Your answer should be very brief. 1.23. What is the ratio of the Exports(as % of merchandise exports) of St. Lucia in 2000 to that in 2001?
Offer a very short reply. 0.73. What is the ratio of the Exports(as % of merchandise exports) in United Arab Emirates in 2000 to that in 2001?
Keep it short and to the point. 0.55. What is the ratio of the Exports(as % of merchandise exports) in Australia in 2000 to that in 2005?
Offer a terse response. 1.64. What is the ratio of the Exports(as % of merchandise exports) of Peru in 2000 to that in 2005?
Provide a succinct answer. 1.7. What is the ratio of the Exports(as % of merchandise exports) of St. Lucia in 2000 to that in 2005?
Ensure brevity in your answer.  1.16. What is the ratio of the Exports(as % of merchandise exports) in United Arab Emirates in 2000 to that in 2005?
Your response must be concise. 0.78. What is the ratio of the Exports(as % of merchandise exports) in Australia in 2000 to that in 2007?
Your response must be concise. 1.86. What is the ratio of the Exports(as % of merchandise exports) of Peru in 2000 to that in 2007?
Your answer should be compact. 2.11. What is the ratio of the Exports(as % of merchandise exports) of St. Lucia in 2000 to that in 2007?
Your answer should be very brief. 1.34. What is the ratio of the Exports(as % of merchandise exports) of United Arab Emirates in 2000 to that in 2007?
Your answer should be compact. 0.69. What is the ratio of the Exports(as % of merchandise exports) of Australia in 2001 to that in 2005?
Give a very brief answer. 1.7. What is the ratio of the Exports(as % of merchandise exports) of Peru in 2001 to that in 2005?
Your answer should be very brief. 1.39. What is the ratio of the Exports(as % of merchandise exports) in St. Lucia in 2001 to that in 2005?
Your answer should be compact. 1.6. What is the ratio of the Exports(as % of merchandise exports) of United Arab Emirates in 2001 to that in 2005?
Provide a short and direct response. 1.44. What is the ratio of the Exports(as % of merchandise exports) of Australia in 2001 to that in 2007?
Offer a very short reply. 1.93. What is the ratio of the Exports(as % of merchandise exports) in Peru in 2001 to that in 2007?
Provide a short and direct response. 1.72. What is the ratio of the Exports(as % of merchandise exports) of St. Lucia in 2001 to that in 2007?
Provide a succinct answer. 1.84. What is the ratio of the Exports(as % of merchandise exports) of United Arab Emirates in 2001 to that in 2007?
Give a very brief answer. 1.27. What is the ratio of the Exports(as % of merchandise exports) of Australia in 2005 to that in 2007?
Give a very brief answer. 1.14. What is the ratio of the Exports(as % of merchandise exports) of Peru in 2005 to that in 2007?
Offer a very short reply. 1.24. What is the ratio of the Exports(as % of merchandise exports) of St. Lucia in 2005 to that in 2007?
Provide a short and direct response. 1.15. What is the ratio of the Exports(as % of merchandise exports) of United Arab Emirates in 2005 to that in 2007?
Ensure brevity in your answer.  0.88. What is the difference between the highest and the second highest Exports(as % of merchandise exports) in Australia?
Give a very brief answer. 0.26. What is the difference between the highest and the second highest Exports(as % of merchandise exports) of Peru?
Your response must be concise. 0.72. What is the difference between the highest and the second highest Exports(as % of merchandise exports) of St. Lucia?
Keep it short and to the point. 0.01. What is the difference between the highest and the second highest Exports(as % of merchandise exports) in United Arab Emirates?
Offer a terse response. 0.07. What is the difference between the highest and the lowest Exports(as % of merchandise exports) of Australia?
Ensure brevity in your answer.  7.49. What is the difference between the highest and the lowest Exports(as % of merchandise exports) of Peru?
Offer a terse response. 2.68. What is the difference between the highest and the lowest Exports(as % of merchandise exports) in St. Lucia?
Make the answer very short. 0.34. What is the difference between the highest and the lowest Exports(as % of merchandise exports) in United Arab Emirates?
Provide a short and direct response. 0.44. 